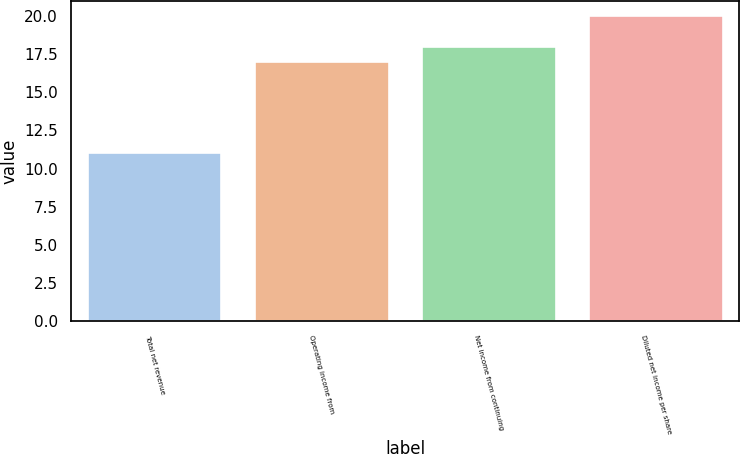Convert chart to OTSL. <chart><loc_0><loc_0><loc_500><loc_500><bar_chart><fcel>Total net revenue<fcel>Operating income from<fcel>Net income from continuing<fcel>Diluted net income per share<nl><fcel>11<fcel>17<fcel>18<fcel>20<nl></chart> 